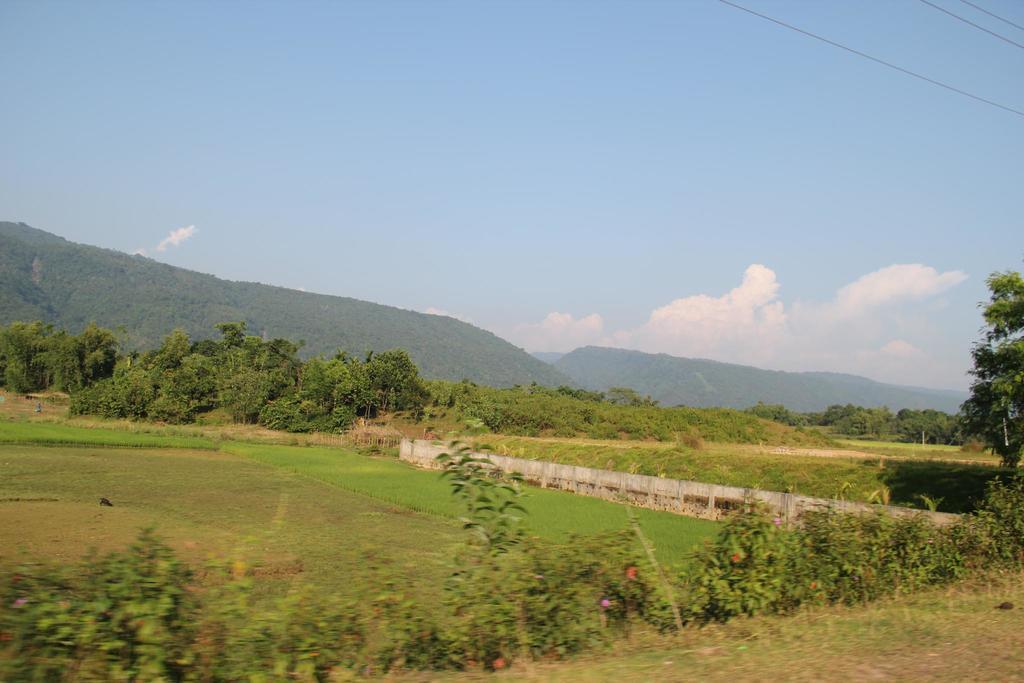Can you describe this image briefly? In the image we can see there is ground which is covered with grass and there are plants and there are lot of trees. There is a road in the middle. 